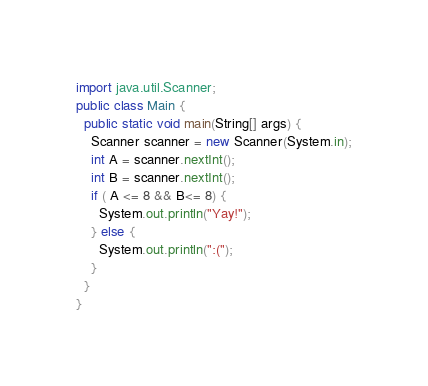Convert code to text. <code><loc_0><loc_0><loc_500><loc_500><_Java_>import java.util.Scanner;
public class Main {
  public static void main(String[] args) {
    Scanner scanner = new Scanner(System.in);
    int A = scanner.nextInt();
    int B = scanner.nextInt();
    if ( A <= 8 && B<= 8) {
      System.out.println("Yay!");
    } else {
      System.out.println(":(");
    }
  }
}</code> 